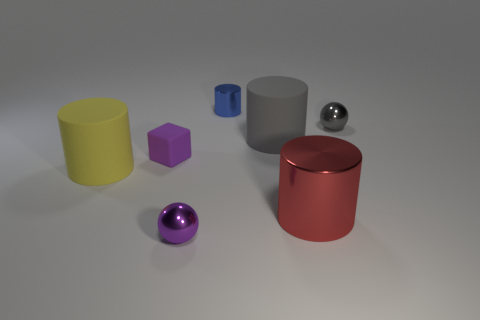There is a metal object that is left of the big gray cylinder and in front of the small gray ball; what size is it?
Ensure brevity in your answer.  Small. Are there fewer small purple matte things than large green objects?
Ensure brevity in your answer.  No. There is a metallic ball in front of the red shiny object; how big is it?
Keep it short and to the point. Small. What is the shape of the rubber object that is both on the left side of the tiny blue cylinder and on the right side of the large yellow matte cylinder?
Provide a short and direct response. Cube. There is another rubber object that is the same shape as the large yellow object; what is its size?
Your answer should be compact. Large. How many big brown blocks are the same material as the tiny cylinder?
Keep it short and to the point. 0. There is a small rubber object; is it the same color as the tiny shiny thing to the left of the tiny blue object?
Keep it short and to the point. Yes. Are there more tiny spheres than objects?
Offer a terse response. No. The big shiny cylinder is what color?
Ensure brevity in your answer.  Red. Is the color of the metallic sphere in front of the tiny rubber object the same as the small rubber cube?
Keep it short and to the point. Yes. 